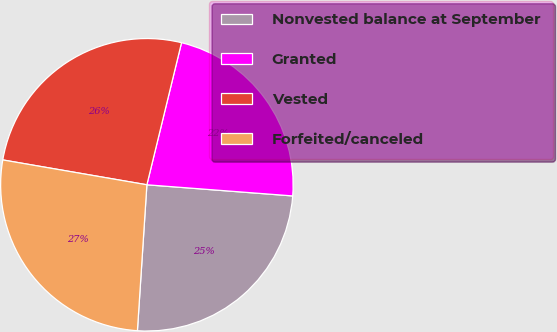Convert chart to OTSL. <chart><loc_0><loc_0><loc_500><loc_500><pie_chart><fcel>Nonvested balance at September<fcel>Granted<fcel>Vested<fcel>Forfeited/canceled<nl><fcel>24.82%<fcel>22.41%<fcel>26.09%<fcel>26.69%<nl></chart> 